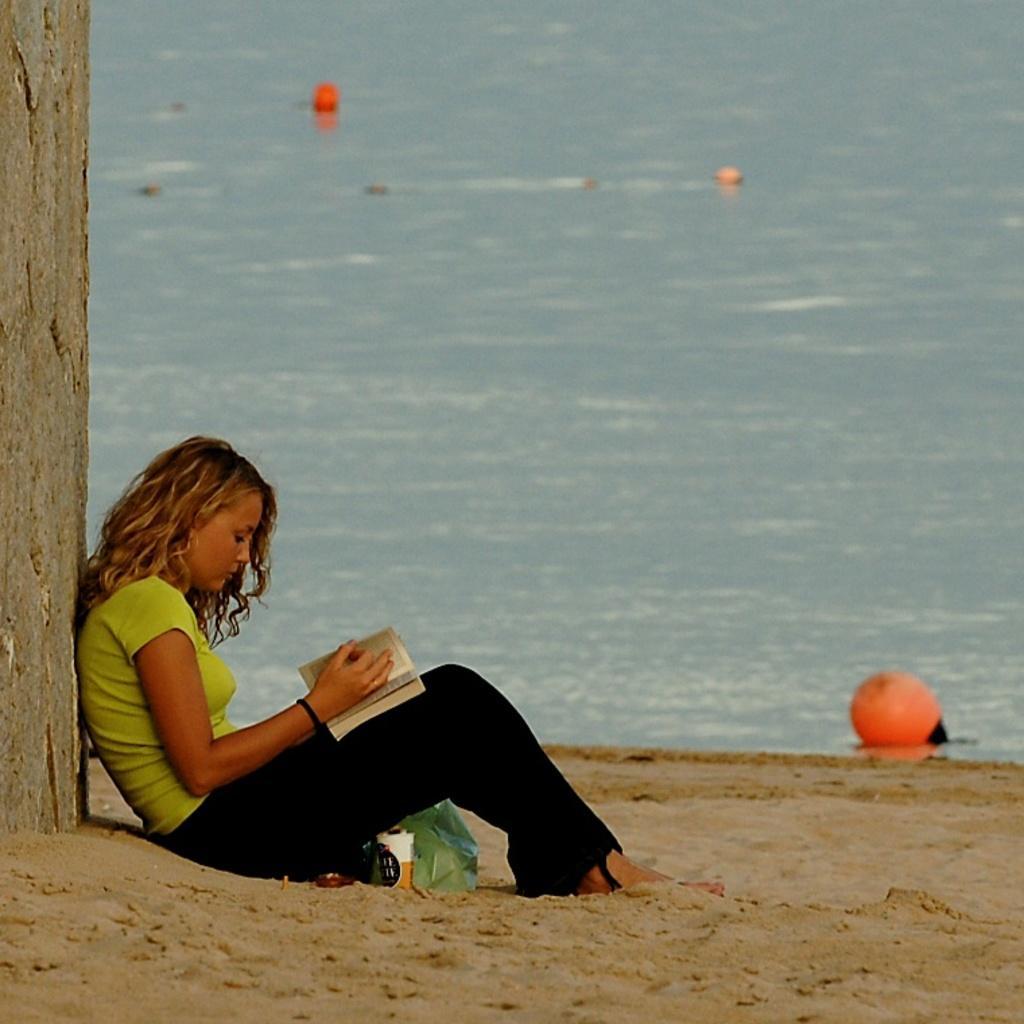Can you describe this image briefly? In this image, we can see a person holding some object is sitting. We can see an object on the left. We can see the ground covered with sand. We can also see some water with a few objects on the top. 